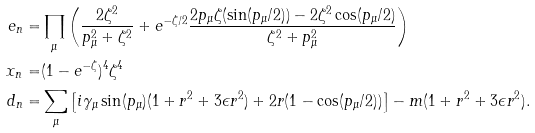<formula> <loc_0><loc_0><loc_500><loc_500>e _ { n } = & \prod _ { \mu } \left ( \frac { 2 \zeta ^ { 2 } } { p _ { \mu } ^ { 2 } + \zeta ^ { 2 } } + e ^ { - \zeta / 2 } \frac { 2 p _ { \mu } \zeta ( \sin ( p _ { \mu } / 2 ) ) - 2 \zeta ^ { 2 } \cos ( p _ { \mu } / 2 ) } { \zeta ^ { 2 } + p ^ { 2 } _ { \mu } } \right ) \\ x _ { n } = & ( 1 - e ^ { - \zeta } ) ^ { 4 } \zeta ^ { 4 } \\ d _ { n } = & \sum _ { \mu } \left [ i \gamma _ { \mu } \sin ( p _ { \mu } ) ( 1 + r ^ { 2 } + 3 \epsilon r ^ { 2 } ) + 2 r ( 1 - \cos ( p _ { \mu } / 2 ) ) \right ] - m ( 1 + r ^ { 2 } + 3 \epsilon r ^ { 2 } ) .</formula> 